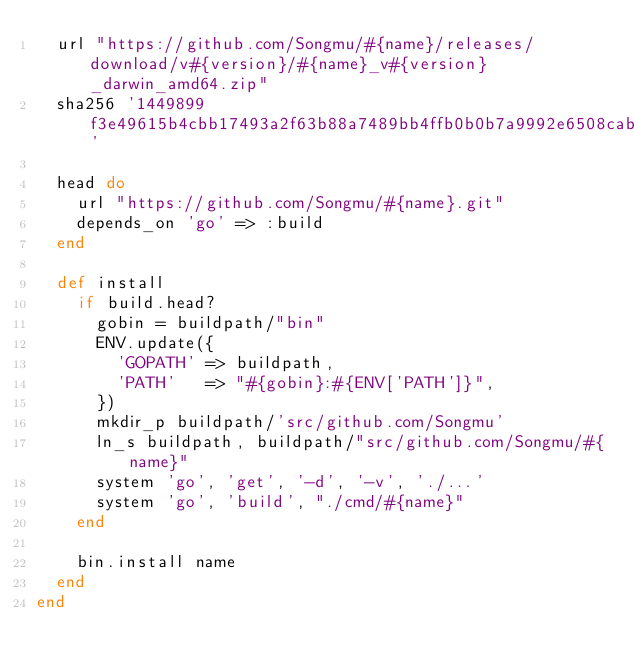Convert code to text. <code><loc_0><loc_0><loc_500><loc_500><_Ruby_>  url "https://github.com/Songmu/#{name}/releases/download/v#{version}/#{name}_v#{version}_darwin_amd64.zip"
  sha256 '1449899f3e49615b4cbb17493a2f63b88a7489bb4ffb0b0b7a9992e6508cab38'

  head do
    url "https://github.com/Songmu/#{name}.git"
    depends_on 'go' => :build
  end

  def install
    if build.head?
      gobin = buildpath/"bin"
      ENV.update({
        'GOPATH' => buildpath,
        'PATH'   => "#{gobin}:#{ENV['PATH']}",
      })
      mkdir_p buildpath/'src/github.com/Songmu'
      ln_s buildpath, buildpath/"src/github.com/Songmu/#{name}"
      system 'go', 'get', '-d', '-v', './...'
      system 'go', 'build', "./cmd/#{name}"
    end

    bin.install name
  end
end
</code> 